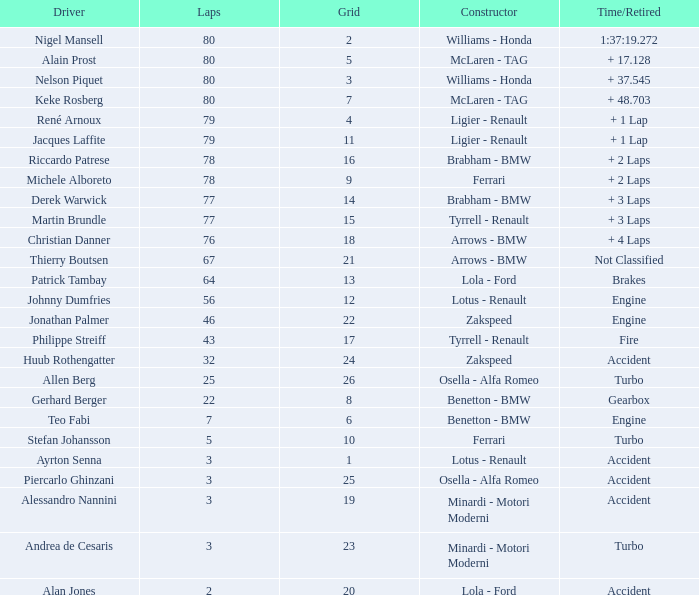What is the time/retired for thierry boutsen? Not Classified. 